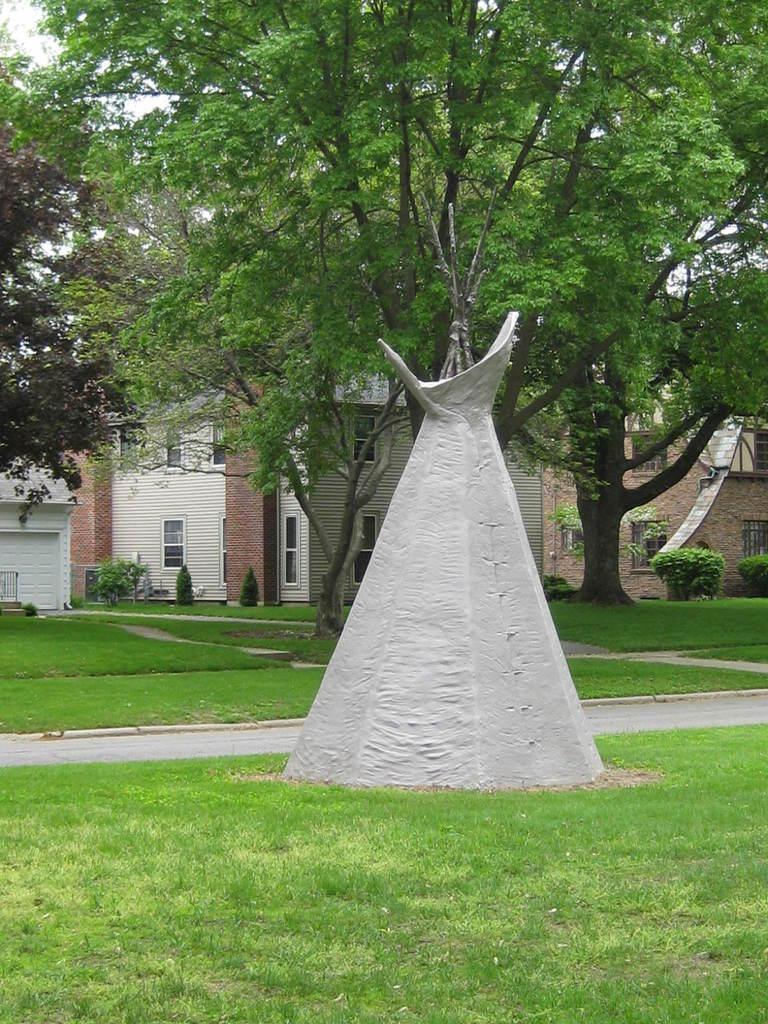Describe this image in one or two sentences. In this picture we can see grass at the bottom, there are trees and plants in the middle, in the background there are some buildings, we can see the sky at the top of the picture. 